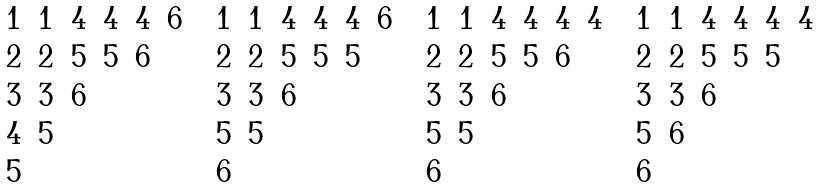Convert formula to latex. <formula><loc_0><loc_0><loc_500><loc_500>\begin{matrix} 1 & 1 & 4 & 4 & 4 & 6 \\ 2 & 2 & 5 & 5 & 6 & \\ 3 & 3 & 6 & & & \\ 4 & 5 & & & & \\ 5 & & & & & \end{matrix} \quad \begin{matrix} 1 & 1 & 4 & 4 & 4 & 6 \\ 2 & 2 & 5 & 5 & 5 & \\ 3 & 3 & 6 & & & \\ 5 & 5 & & & & \\ 6 & & & & & \end{matrix} \quad \begin{matrix} 1 & 1 & 4 & 4 & 4 & 4 \\ 2 & 2 & 5 & 5 & 6 & \\ 3 & 3 & 6 & & & \\ 5 & 5 & & & & \\ 6 & & & & & \end{matrix} \quad \begin{matrix} 1 & 1 & 4 & 4 & 4 & 4 \\ 2 & 2 & 5 & 5 & 5 & \\ 3 & 3 & 6 & & & \\ 5 & 6 & & & & \\ 6 & & & & & \end{matrix}</formula> 